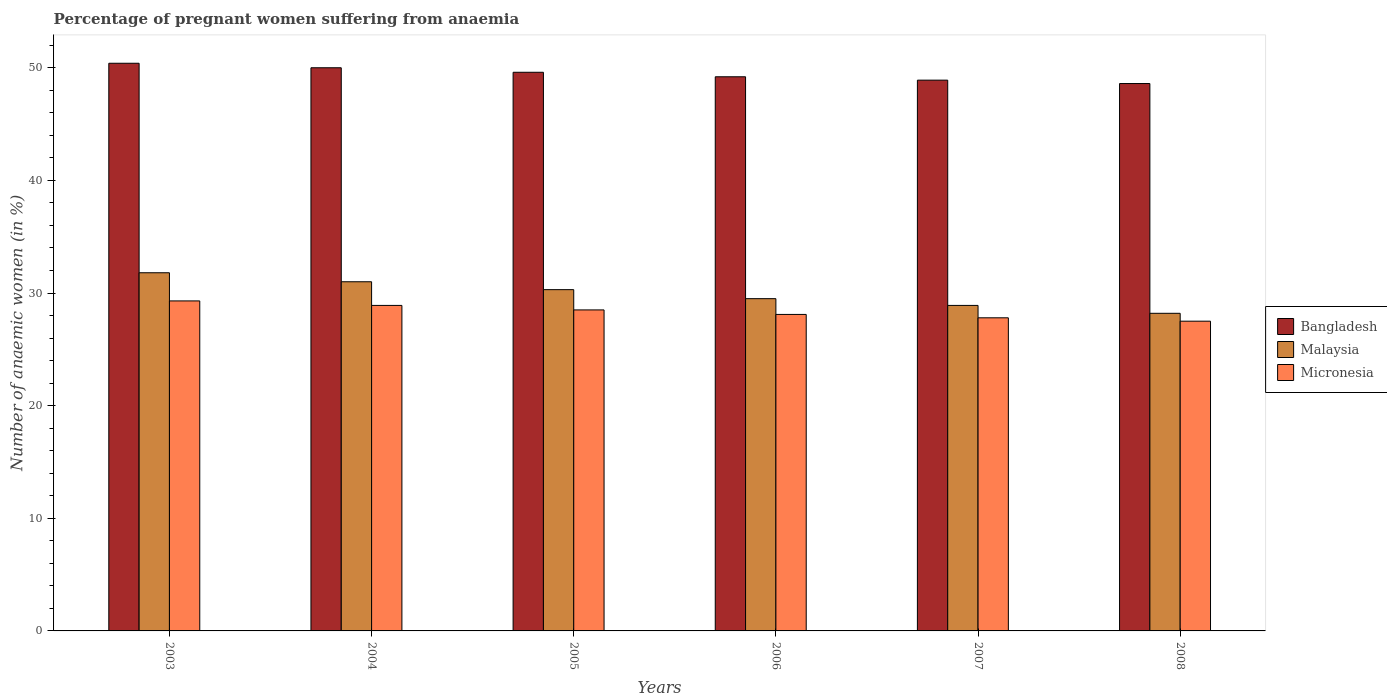How many different coloured bars are there?
Make the answer very short. 3. How many groups of bars are there?
Your response must be concise. 6. Are the number of bars on each tick of the X-axis equal?
Your answer should be very brief. Yes. How many bars are there on the 1st tick from the left?
Provide a short and direct response. 3. What is the label of the 6th group of bars from the left?
Your answer should be very brief. 2008. In how many cases, is the number of bars for a given year not equal to the number of legend labels?
Your response must be concise. 0. What is the number of anaemic women in Malaysia in 2005?
Give a very brief answer. 30.3. Across all years, what is the maximum number of anaemic women in Malaysia?
Keep it short and to the point. 31.8. Across all years, what is the minimum number of anaemic women in Bangladesh?
Make the answer very short. 48.6. In which year was the number of anaemic women in Malaysia maximum?
Your answer should be very brief. 2003. In which year was the number of anaemic women in Bangladesh minimum?
Offer a very short reply. 2008. What is the total number of anaemic women in Micronesia in the graph?
Offer a terse response. 170.1. What is the difference between the number of anaemic women in Bangladesh in 2005 and that in 2007?
Keep it short and to the point. 0.7. What is the difference between the number of anaemic women in Bangladesh in 2005 and the number of anaemic women in Micronesia in 2004?
Provide a short and direct response. 20.7. What is the average number of anaemic women in Bangladesh per year?
Make the answer very short. 49.45. In the year 2006, what is the difference between the number of anaemic women in Malaysia and number of anaemic women in Bangladesh?
Offer a terse response. -19.7. What is the ratio of the number of anaemic women in Bangladesh in 2003 to that in 2006?
Your response must be concise. 1.02. Is the number of anaemic women in Malaysia in 2005 less than that in 2006?
Your answer should be compact. No. What is the difference between the highest and the second highest number of anaemic women in Micronesia?
Your response must be concise. 0.4. What is the difference between the highest and the lowest number of anaemic women in Micronesia?
Your answer should be compact. 1.8. In how many years, is the number of anaemic women in Malaysia greater than the average number of anaemic women in Malaysia taken over all years?
Make the answer very short. 3. Is the sum of the number of anaemic women in Malaysia in 2003 and 2005 greater than the maximum number of anaemic women in Bangladesh across all years?
Offer a very short reply. Yes. What does the 3rd bar from the left in 2007 represents?
Provide a short and direct response. Micronesia. What does the 1st bar from the right in 2006 represents?
Provide a short and direct response. Micronesia. How many bars are there?
Ensure brevity in your answer.  18. Are the values on the major ticks of Y-axis written in scientific E-notation?
Provide a succinct answer. No. How are the legend labels stacked?
Provide a succinct answer. Vertical. What is the title of the graph?
Your response must be concise. Percentage of pregnant women suffering from anaemia. Does "Turkmenistan" appear as one of the legend labels in the graph?
Provide a short and direct response. No. What is the label or title of the X-axis?
Your answer should be very brief. Years. What is the label or title of the Y-axis?
Make the answer very short. Number of anaemic women (in %). What is the Number of anaemic women (in %) in Bangladesh in 2003?
Make the answer very short. 50.4. What is the Number of anaemic women (in %) of Malaysia in 2003?
Make the answer very short. 31.8. What is the Number of anaemic women (in %) of Micronesia in 2003?
Ensure brevity in your answer.  29.3. What is the Number of anaemic women (in %) of Micronesia in 2004?
Ensure brevity in your answer.  28.9. What is the Number of anaemic women (in %) in Bangladesh in 2005?
Ensure brevity in your answer.  49.6. What is the Number of anaemic women (in %) in Malaysia in 2005?
Offer a terse response. 30.3. What is the Number of anaemic women (in %) of Bangladesh in 2006?
Keep it short and to the point. 49.2. What is the Number of anaemic women (in %) of Malaysia in 2006?
Provide a short and direct response. 29.5. What is the Number of anaemic women (in %) in Micronesia in 2006?
Your answer should be compact. 28.1. What is the Number of anaemic women (in %) of Bangladesh in 2007?
Provide a short and direct response. 48.9. What is the Number of anaemic women (in %) of Malaysia in 2007?
Offer a terse response. 28.9. What is the Number of anaemic women (in %) of Micronesia in 2007?
Your response must be concise. 27.8. What is the Number of anaemic women (in %) in Bangladesh in 2008?
Give a very brief answer. 48.6. What is the Number of anaemic women (in %) in Malaysia in 2008?
Give a very brief answer. 28.2. Across all years, what is the maximum Number of anaemic women (in %) of Bangladesh?
Ensure brevity in your answer.  50.4. Across all years, what is the maximum Number of anaemic women (in %) of Malaysia?
Keep it short and to the point. 31.8. Across all years, what is the maximum Number of anaemic women (in %) in Micronesia?
Provide a short and direct response. 29.3. Across all years, what is the minimum Number of anaemic women (in %) of Bangladesh?
Provide a short and direct response. 48.6. Across all years, what is the minimum Number of anaemic women (in %) in Malaysia?
Your answer should be very brief. 28.2. Across all years, what is the minimum Number of anaemic women (in %) of Micronesia?
Your response must be concise. 27.5. What is the total Number of anaemic women (in %) of Bangladesh in the graph?
Provide a succinct answer. 296.7. What is the total Number of anaemic women (in %) in Malaysia in the graph?
Provide a succinct answer. 179.7. What is the total Number of anaemic women (in %) in Micronesia in the graph?
Provide a succinct answer. 170.1. What is the difference between the Number of anaemic women (in %) in Bangladesh in 2003 and that in 2004?
Offer a terse response. 0.4. What is the difference between the Number of anaemic women (in %) in Bangladesh in 2003 and that in 2005?
Your answer should be very brief. 0.8. What is the difference between the Number of anaemic women (in %) of Bangladesh in 2003 and that in 2006?
Offer a terse response. 1.2. What is the difference between the Number of anaemic women (in %) of Malaysia in 2003 and that in 2006?
Your response must be concise. 2.3. What is the difference between the Number of anaemic women (in %) in Micronesia in 2003 and that in 2006?
Offer a very short reply. 1.2. What is the difference between the Number of anaemic women (in %) of Malaysia in 2003 and that in 2007?
Offer a very short reply. 2.9. What is the difference between the Number of anaemic women (in %) in Micronesia in 2003 and that in 2007?
Provide a short and direct response. 1.5. What is the difference between the Number of anaemic women (in %) of Bangladesh in 2003 and that in 2008?
Give a very brief answer. 1.8. What is the difference between the Number of anaemic women (in %) in Malaysia in 2003 and that in 2008?
Offer a terse response. 3.6. What is the difference between the Number of anaemic women (in %) of Micronesia in 2003 and that in 2008?
Give a very brief answer. 1.8. What is the difference between the Number of anaemic women (in %) in Malaysia in 2004 and that in 2005?
Your response must be concise. 0.7. What is the difference between the Number of anaemic women (in %) in Bangladesh in 2004 and that in 2006?
Your answer should be compact. 0.8. What is the difference between the Number of anaemic women (in %) in Micronesia in 2004 and that in 2006?
Offer a very short reply. 0.8. What is the difference between the Number of anaemic women (in %) in Bangladesh in 2004 and that in 2007?
Your answer should be very brief. 1.1. What is the difference between the Number of anaemic women (in %) in Malaysia in 2004 and that in 2007?
Offer a terse response. 2.1. What is the difference between the Number of anaemic women (in %) in Bangladesh in 2004 and that in 2008?
Provide a succinct answer. 1.4. What is the difference between the Number of anaemic women (in %) in Micronesia in 2004 and that in 2008?
Give a very brief answer. 1.4. What is the difference between the Number of anaemic women (in %) in Bangladesh in 2005 and that in 2006?
Your answer should be compact. 0.4. What is the difference between the Number of anaemic women (in %) of Malaysia in 2005 and that in 2006?
Your response must be concise. 0.8. What is the difference between the Number of anaemic women (in %) of Bangladesh in 2005 and that in 2007?
Ensure brevity in your answer.  0.7. What is the difference between the Number of anaemic women (in %) in Micronesia in 2005 and that in 2007?
Your answer should be compact. 0.7. What is the difference between the Number of anaemic women (in %) in Bangladesh in 2005 and that in 2008?
Your response must be concise. 1. What is the difference between the Number of anaemic women (in %) of Malaysia in 2005 and that in 2008?
Provide a succinct answer. 2.1. What is the difference between the Number of anaemic women (in %) of Micronesia in 2007 and that in 2008?
Offer a terse response. 0.3. What is the difference between the Number of anaemic women (in %) in Bangladesh in 2003 and the Number of anaemic women (in %) in Malaysia in 2004?
Provide a succinct answer. 19.4. What is the difference between the Number of anaemic women (in %) of Malaysia in 2003 and the Number of anaemic women (in %) of Micronesia in 2004?
Your answer should be compact. 2.9. What is the difference between the Number of anaemic women (in %) in Bangladesh in 2003 and the Number of anaemic women (in %) in Malaysia in 2005?
Your answer should be compact. 20.1. What is the difference between the Number of anaemic women (in %) in Bangladesh in 2003 and the Number of anaemic women (in %) in Micronesia in 2005?
Offer a very short reply. 21.9. What is the difference between the Number of anaemic women (in %) of Malaysia in 2003 and the Number of anaemic women (in %) of Micronesia in 2005?
Ensure brevity in your answer.  3.3. What is the difference between the Number of anaemic women (in %) in Bangladesh in 2003 and the Number of anaemic women (in %) in Malaysia in 2006?
Keep it short and to the point. 20.9. What is the difference between the Number of anaemic women (in %) of Bangladesh in 2003 and the Number of anaemic women (in %) of Micronesia in 2006?
Offer a terse response. 22.3. What is the difference between the Number of anaemic women (in %) of Bangladesh in 2003 and the Number of anaemic women (in %) of Micronesia in 2007?
Make the answer very short. 22.6. What is the difference between the Number of anaemic women (in %) of Malaysia in 2003 and the Number of anaemic women (in %) of Micronesia in 2007?
Provide a succinct answer. 4. What is the difference between the Number of anaemic women (in %) in Bangladesh in 2003 and the Number of anaemic women (in %) in Malaysia in 2008?
Offer a very short reply. 22.2. What is the difference between the Number of anaemic women (in %) in Bangladesh in 2003 and the Number of anaemic women (in %) in Micronesia in 2008?
Provide a short and direct response. 22.9. What is the difference between the Number of anaemic women (in %) of Malaysia in 2003 and the Number of anaemic women (in %) of Micronesia in 2008?
Provide a succinct answer. 4.3. What is the difference between the Number of anaemic women (in %) in Malaysia in 2004 and the Number of anaemic women (in %) in Micronesia in 2005?
Provide a short and direct response. 2.5. What is the difference between the Number of anaemic women (in %) in Bangladesh in 2004 and the Number of anaemic women (in %) in Malaysia in 2006?
Make the answer very short. 20.5. What is the difference between the Number of anaemic women (in %) of Bangladesh in 2004 and the Number of anaemic women (in %) of Micronesia in 2006?
Offer a very short reply. 21.9. What is the difference between the Number of anaemic women (in %) in Bangladesh in 2004 and the Number of anaemic women (in %) in Malaysia in 2007?
Your answer should be very brief. 21.1. What is the difference between the Number of anaemic women (in %) in Bangladesh in 2004 and the Number of anaemic women (in %) in Micronesia in 2007?
Keep it short and to the point. 22.2. What is the difference between the Number of anaemic women (in %) of Bangladesh in 2004 and the Number of anaemic women (in %) of Malaysia in 2008?
Offer a terse response. 21.8. What is the difference between the Number of anaemic women (in %) in Bangladesh in 2005 and the Number of anaemic women (in %) in Malaysia in 2006?
Provide a short and direct response. 20.1. What is the difference between the Number of anaemic women (in %) in Bangladesh in 2005 and the Number of anaemic women (in %) in Micronesia in 2006?
Provide a short and direct response. 21.5. What is the difference between the Number of anaemic women (in %) in Malaysia in 2005 and the Number of anaemic women (in %) in Micronesia in 2006?
Offer a terse response. 2.2. What is the difference between the Number of anaemic women (in %) in Bangladesh in 2005 and the Number of anaemic women (in %) in Malaysia in 2007?
Make the answer very short. 20.7. What is the difference between the Number of anaemic women (in %) of Bangladesh in 2005 and the Number of anaemic women (in %) of Micronesia in 2007?
Your answer should be compact. 21.8. What is the difference between the Number of anaemic women (in %) in Malaysia in 2005 and the Number of anaemic women (in %) in Micronesia in 2007?
Your response must be concise. 2.5. What is the difference between the Number of anaemic women (in %) in Bangladesh in 2005 and the Number of anaemic women (in %) in Malaysia in 2008?
Provide a succinct answer. 21.4. What is the difference between the Number of anaemic women (in %) in Bangladesh in 2005 and the Number of anaemic women (in %) in Micronesia in 2008?
Offer a terse response. 22.1. What is the difference between the Number of anaemic women (in %) of Bangladesh in 2006 and the Number of anaemic women (in %) of Malaysia in 2007?
Your answer should be very brief. 20.3. What is the difference between the Number of anaemic women (in %) in Bangladesh in 2006 and the Number of anaemic women (in %) in Micronesia in 2007?
Your answer should be compact. 21.4. What is the difference between the Number of anaemic women (in %) of Malaysia in 2006 and the Number of anaemic women (in %) of Micronesia in 2007?
Keep it short and to the point. 1.7. What is the difference between the Number of anaemic women (in %) in Bangladesh in 2006 and the Number of anaemic women (in %) in Micronesia in 2008?
Provide a succinct answer. 21.7. What is the difference between the Number of anaemic women (in %) in Malaysia in 2006 and the Number of anaemic women (in %) in Micronesia in 2008?
Keep it short and to the point. 2. What is the difference between the Number of anaemic women (in %) in Bangladesh in 2007 and the Number of anaemic women (in %) in Malaysia in 2008?
Keep it short and to the point. 20.7. What is the difference between the Number of anaemic women (in %) in Bangladesh in 2007 and the Number of anaemic women (in %) in Micronesia in 2008?
Offer a terse response. 21.4. What is the difference between the Number of anaemic women (in %) of Malaysia in 2007 and the Number of anaemic women (in %) of Micronesia in 2008?
Offer a very short reply. 1.4. What is the average Number of anaemic women (in %) in Bangladesh per year?
Keep it short and to the point. 49.45. What is the average Number of anaemic women (in %) in Malaysia per year?
Your answer should be compact. 29.95. What is the average Number of anaemic women (in %) of Micronesia per year?
Make the answer very short. 28.35. In the year 2003, what is the difference between the Number of anaemic women (in %) of Bangladesh and Number of anaemic women (in %) of Micronesia?
Make the answer very short. 21.1. In the year 2003, what is the difference between the Number of anaemic women (in %) of Malaysia and Number of anaemic women (in %) of Micronesia?
Keep it short and to the point. 2.5. In the year 2004, what is the difference between the Number of anaemic women (in %) in Bangladesh and Number of anaemic women (in %) in Micronesia?
Make the answer very short. 21.1. In the year 2005, what is the difference between the Number of anaemic women (in %) in Bangladesh and Number of anaemic women (in %) in Malaysia?
Ensure brevity in your answer.  19.3. In the year 2005, what is the difference between the Number of anaemic women (in %) in Bangladesh and Number of anaemic women (in %) in Micronesia?
Make the answer very short. 21.1. In the year 2006, what is the difference between the Number of anaemic women (in %) of Bangladesh and Number of anaemic women (in %) of Micronesia?
Give a very brief answer. 21.1. In the year 2006, what is the difference between the Number of anaemic women (in %) of Malaysia and Number of anaemic women (in %) of Micronesia?
Your answer should be very brief. 1.4. In the year 2007, what is the difference between the Number of anaemic women (in %) in Bangladesh and Number of anaemic women (in %) in Micronesia?
Your answer should be compact. 21.1. In the year 2008, what is the difference between the Number of anaemic women (in %) of Bangladesh and Number of anaemic women (in %) of Malaysia?
Your answer should be compact. 20.4. In the year 2008, what is the difference between the Number of anaemic women (in %) of Bangladesh and Number of anaemic women (in %) of Micronesia?
Make the answer very short. 21.1. What is the ratio of the Number of anaemic women (in %) in Malaysia in 2003 to that in 2004?
Your answer should be compact. 1.03. What is the ratio of the Number of anaemic women (in %) of Micronesia in 2003 to that in 2004?
Your response must be concise. 1.01. What is the ratio of the Number of anaemic women (in %) of Bangladesh in 2003 to that in 2005?
Your answer should be compact. 1.02. What is the ratio of the Number of anaemic women (in %) of Malaysia in 2003 to that in 2005?
Ensure brevity in your answer.  1.05. What is the ratio of the Number of anaemic women (in %) of Micronesia in 2003 to that in 2005?
Your response must be concise. 1.03. What is the ratio of the Number of anaemic women (in %) in Bangladesh in 2003 to that in 2006?
Provide a succinct answer. 1.02. What is the ratio of the Number of anaemic women (in %) in Malaysia in 2003 to that in 2006?
Give a very brief answer. 1.08. What is the ratio of the Number of anaemic women (in %) of Micronesia in 2003 to that in 2006?
Ensure brevity in your answer.  1.04. What is the ratio of the Number of anaemic women (in %) in Bangladesh in 2003 to that in 2007?
Give a very brief answer. 1.03. What is the ratio of the Number of anaemic women (in %) in Malaysia in 2003 to that in 2007?
Your response must be concise. 1.1. What is the ratio of the Number of anaemic women (in %) in Micronesia in 2003 to that in 2007?
Offer a terse response. 1.05. What is the ratio of the Number of anaemic women (in %) of Malaysia in 2003 to that in 2008?
Offer a terse response. 1.13. What is the ratio of the Number of anaemic women (in %) in Micronesia in 2003 to that in 2008?
Provide a short and direct response. 1.07. What is the ratio of the Number of anaemic women (in %) in Malaysia in 2004 to that in 2005?
Give a very brief answer. 1.02. What is the ratio of the Number of anaemic women (in %) of Micronesia in 2004 to that in 2005?
Offer a terse response. 1.01. What is the ratio of the Number of anaemic women (in %) in Bangladesh in 2004 to that in 2006?
Provide a short and direct response. 1.02. What is the ratio of the Number of anaemic women (in %) in Malaysia in 2004 to that in 2006?
Make the answer very short. 1.05. What is the ratio of the Number of anaemic women (in %) in Micronesia in 2004 to that in 2006?
Ensure brevity in your answer.  1.03. What is the ratio of the Number of anaemic women (in %) in Bangladesh in 2004 to that in 2007?
Offer a very short reply. 1.02. What is the ratio of the Number of anaemic women (in %) in Malaysia in 2004 to that in 2007?
Give a very brief answer. 1.07. What is the ratio of the Number of anaemic women (in %) in Micronesia in 2004 to that in 2007?
Your answer should be compact. 1.04. What is the ratio of the Number of anaemic women (in %) of Bangladesh in 2004 to that in 2008?
Offer a terse response. 1.03. What is the ratio of the Number of anaemic women (in %) in Malaysia in 2004 to that in 2008?
Offer a terse response. 1.1. What is the ratio of the Number of anaemic women (in %) of Micronesia in 2004 to that in 2008?
Your response must be concise. 1.05. What is the ratio of the Number of anaemic women (in %) in Malaysia in 2005 to that in 2006?
Offer a terse response. 1.03. What is the ratio of the Number of anaemic women (in %) in Micronesia in 2005 to that in 2006?
Provide a short and direct response. 1.01. What is the ratio of the Number of anaemic women (in %) of Bangladesh in 2005 to that in 2007?
Offer a terse response. 1.01. What is the ratio of the Number of anaemic women (in %) in Malaysia in 2005 to that in 2007?
Offer a terse response. 1.05. What is the ratio of the Number of anaemic women (in %) of Micronesia in 2005 to that in 2007?
Offer a very short reply. 1.03. What is the ratio of the Number of anaemic women (in %) in Bangladesh in 2005 to that in 2008?
Make the answer very short. 1.02. What is the ratio of the Number of anaemic women (in %) of Malaysia in 2005 to that in 2008?
Ensure brevity in your answer.  1.07. What is the ratio of the Number of anaemic women (in %) of Micronesia in 2005 to that in 2008?
Your answer should be very brief. 1.04. What is the ratio of the Number of anaemic women (in %) in Bangladesh in 2006 to that in 2007?
Your response must be concise. 1.01. What is the ratio of the Number of anaemic women (in %) of Malaysia in 2006 to that in 2007?
Give a very brief answer. 1.02. What is the ratio of the Number of anaemic women (in %) of Micronesia in 2006 to that in 2007?
Keep it short and to the point. 1.01. What is the ratio of the Number of anaemic women (in %) of Bangladesh in 2006 to that in 2008?
Give a very brief answer. 1.01. What is the ratio of the Number of anaemic women (in %) in Malaysia in 2006 to that in 2008?
Give a very brief answer. 1.05. What is the ratio of the Number of anaemic women (in %) of Micronesia in 2006 to that in 2008?
Provide a short and direct response. 1.02. What is the ratio of the Number of anaemic women (in %) in Bangladesh in 2007 to that in 2008?
Your answer should be very brief. 1.01. What is the ratio of the Number of anaemic women (in %) in Malaysia in 2007 to that in 2008?
Offer a terse response. 1.02. What is the ratio of the Number of anaemic women (in %) of Micronesia in 2007 to that in 2008?
Keep it short and to the point. 1.01. 